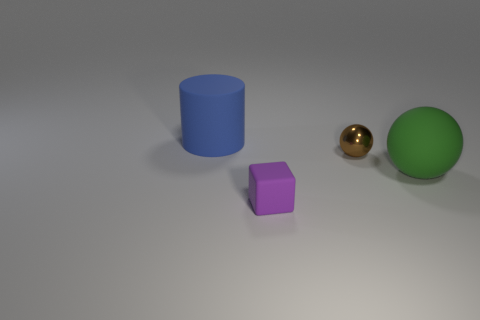How would the perception of the scene change if the lighting was different? If the lighting changed, it would alter the shadows and highlights on the objects, potentially changing the mood and depth perception of the scene. Different types of lighting could change the texture appearance, make the colors more vibrant or subdued, and create a different atmosphere, whether more dramatic or flatter. 